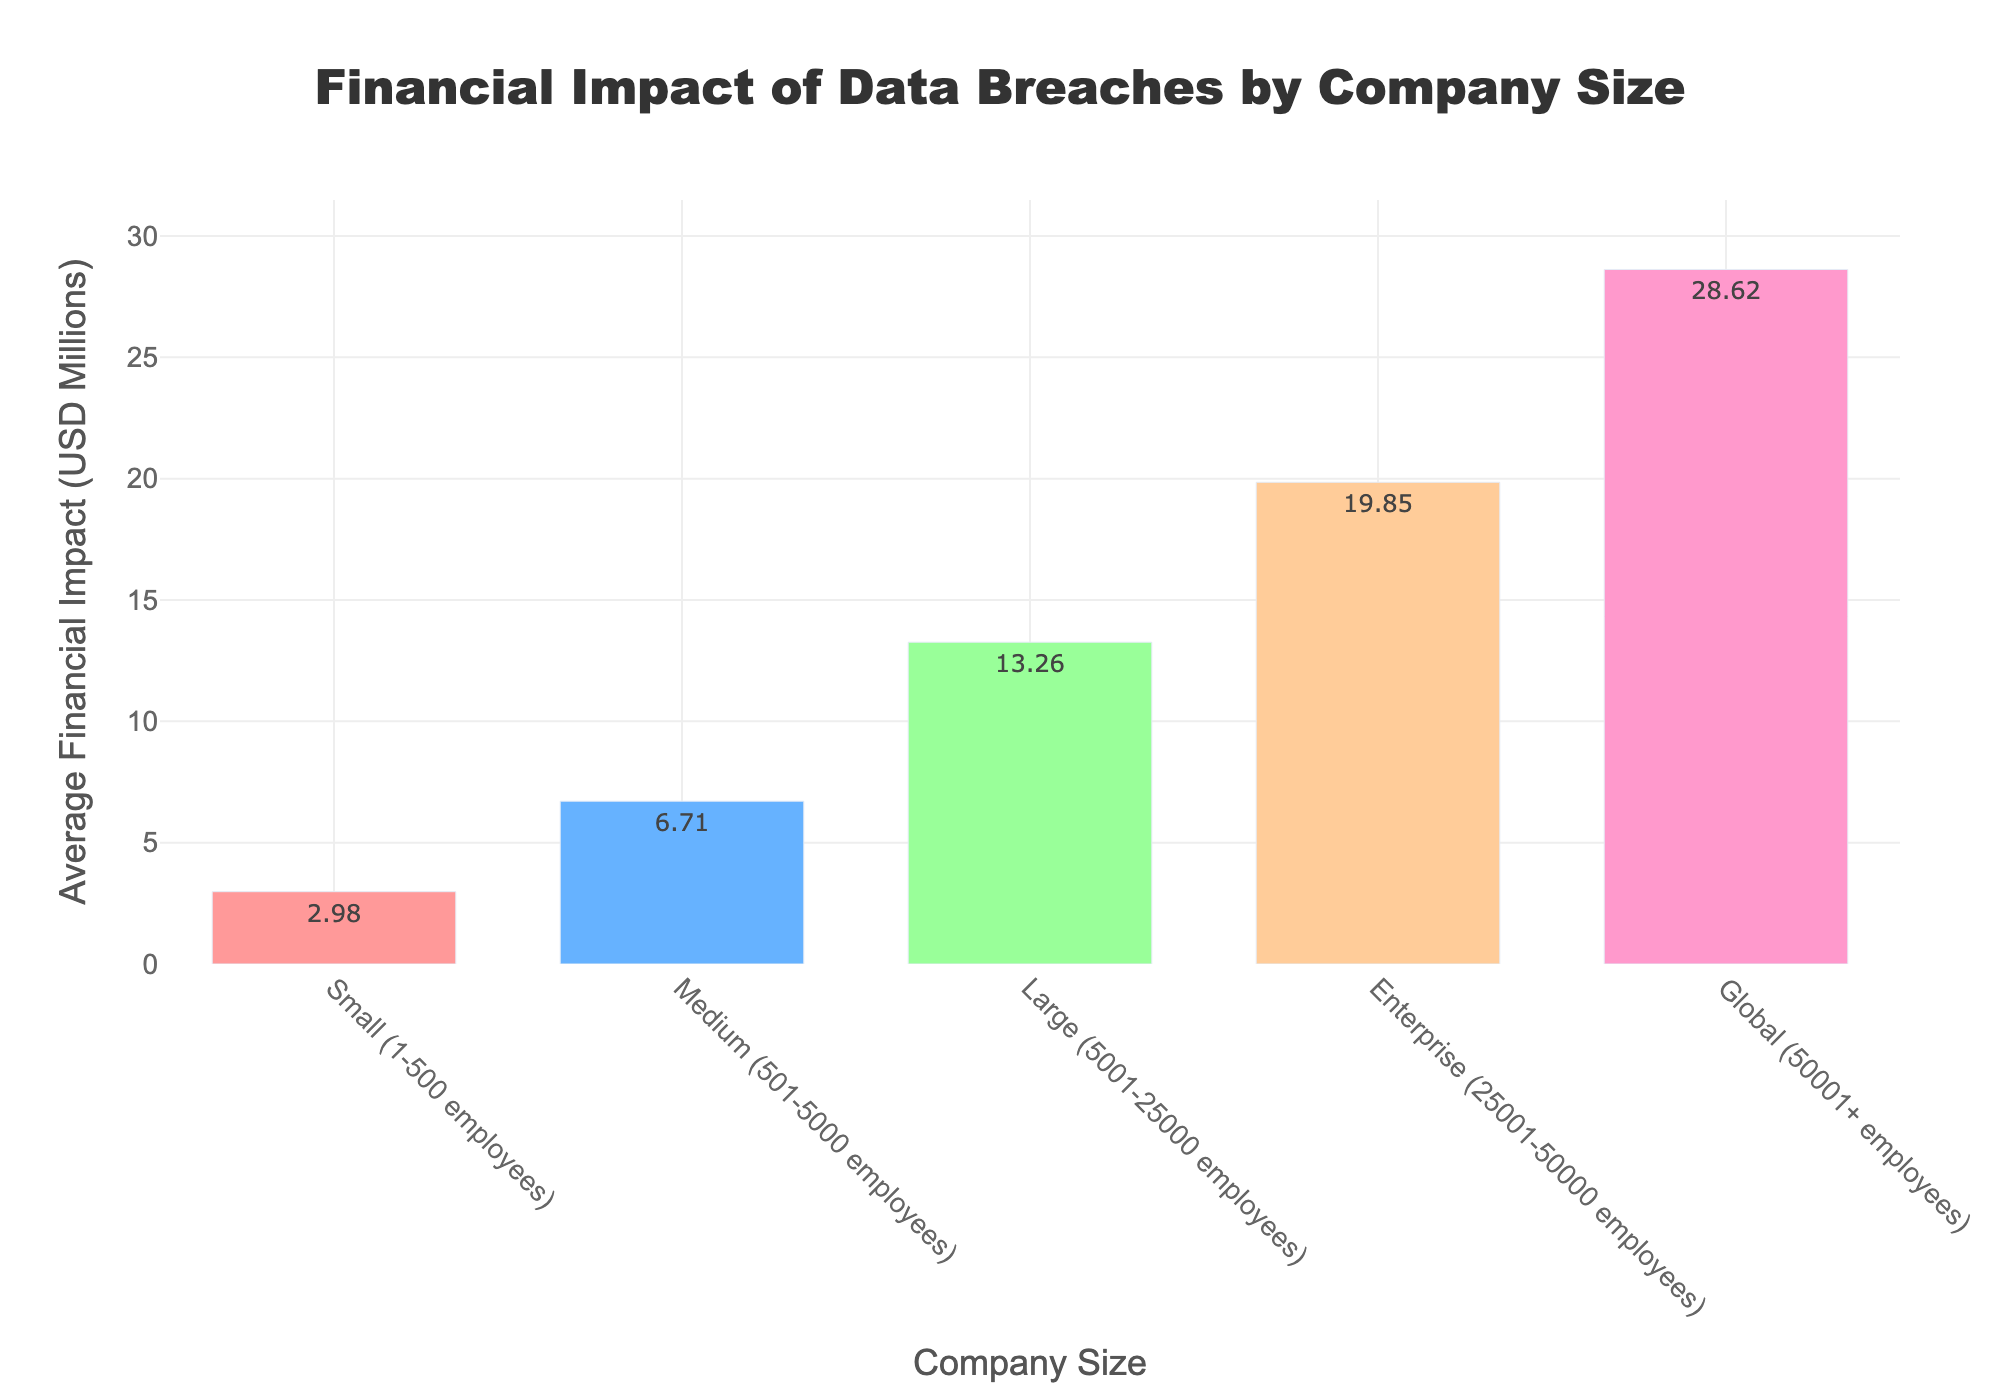What’s the average financial impact of data breaches on small companies? Locate the bar labeled "Small (1-500 employees)" and refer to its height which represents the average financial impact. The label above the bar shows the value 2.98 USD millions.
Answer: 2.98 Which company size group sees the highest financial impact from data breaches? Identify the tallest bar in the chart, which corresponds to the "Global (50001+ employees)" group. The value above this bar is the highest at 28.62 USD millions.
Answer: Global (50001+ employees) What is the difference between the average financial impact on medium and large companies? Locate the bars for "Medium (501-5000 employees)" and "Large (5001-25000 employees)". The heights are 6.71 for medium and 13.26 for large. Subtract 6.71 from 13.26 to find the difference.
Answer: 6.55 Does the financial impact of data breaches more than double from small to medium companies? Compare the heights of the "Small (1-500 employees)" bar (2.98) and the "Medium (501-5000 employees)" bar (6.71). Doubling 2.98 equals 5.96, which is less than 6.71, so the impact more than doubles.
Answer: Yes Which two consecutive company size groups have the smallest increase in financial impact? Compare the differences between consecutive groups: Small to Medium is 6.71 - 2.98 = 3.73, Medium to Large is 13.26 - 6.71 = 6.55, Large to Enterprise is 19.85 - 13.26 = 6.59, and Enterprise to Global is 28.62 - 19.85 = 8.77. The smallest increase is from Small to Medium, which is 3.73.
Answer: Small to Medium What is the total financial impact of data breaches on small, medium, and large companies combined? Add the values for "Small (2.98)", "Medium (6.71)", and "Large (13.26)" companies. The total is 2.98 + 6.71 + 13.26 = 22.95 USD millions.
Answer: 22.95 By how much does the financial impact increase from enterprise to global companies? Subtract the height of the "Enterprise (25001-50000 employees)" bar (19.85) from the "Global (50001+ employees)" bar (28.62). The increase is 28.62 - 19.85 = 8.77.
Answer: 8.77 Which company size groups are represented with shades of blue? Identify the colors of the bars. The bars for "Medium (501-5000 employees)" and "Enterprise (25001-50000 employees)" are shades of blue.
Answer: Medium and Enterprise What is the ratio of financial impact between the largest (global) and smallest (small) company groups? Divide the impact on "Global (50001+ employees)" (28.62) by the impact on "Small (1-500 employees)" (2.98). The ratio is 28.62 / 2.98 ≈ 9.60.
Answer: 9.60 What is the sum of the average financial impacts for enterprise and global companies? Add the values for "Enterprise (19.85)" and "Global (28.62)" companies. The sum is 19.85 + 28.62 = 48.47 USD millions.
Answer: 48.47 